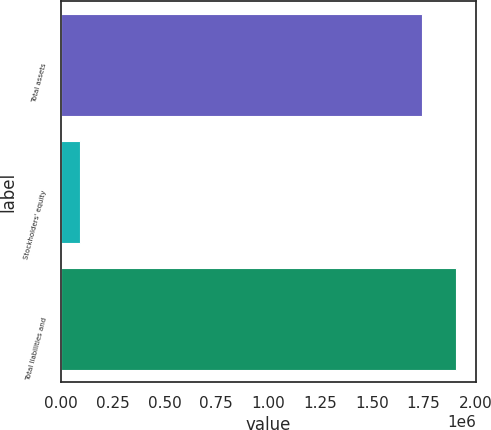Convert chart to OTSL. <chart><loc_0><loc_0><loc_500><loc_500><bar_chart><fcel>Total assets<fcel>Stockholders' equity<fcel>Total liabilities and<nl><fcel>1.74156e+06<fcel>93831<fcel>1.90633e+06<nl></chart> 